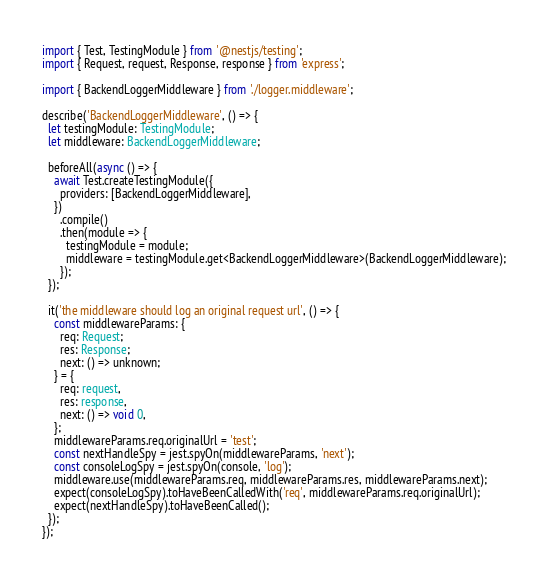<code> <loc_0><loc_0><loc_500><loc_500><_TypeScript_>import { Test, TestingModule } from '@nestjs/testing';
import { Request, request, Response, response } from 'express';

import { BackendLoggerMiddleware } from './logger.middleware';

describe('BackendLoggerMiddleware', () => {
  let testingModule: TestingModule;
  let middleware: BackendLoggerMiddleware;

  beforeAll(async () => {
    await Test.createTestingModule({
      providers: [BackendLoggerMiddleware],
    })
      .compile()
      .then(module => {
        testingModule = module;
        middleware = testingModule.get<BackendLoggerMiddleware>(BackendLoggerMiddleware);
      });
  });

  it('the middleware should log an original request url', () => {
    const middlewareParams: {
      req: Request;
      res: Response;
      next: () => unknown;
    } = {
      req: request,
      res: response,
      next: () => void 0,
    };
    middlewareParams.req.originalUrl = 'test';
    const nextHandleSpy = jest.spyOn(middlewareParams, 'next');
    const consoleLogSpy = jest.spyOn(console, 'log');
    middleware.use(middlewareParams.req, middlewareParams.res, middlewareParams.next);
    expect(consoleLogSpy).toHaveBeenCalledWith('req', middlewareParams.req.originalUrl);
    expect(nextHandleSpy).toHaveBeenCalled();
  });
});
</code> 